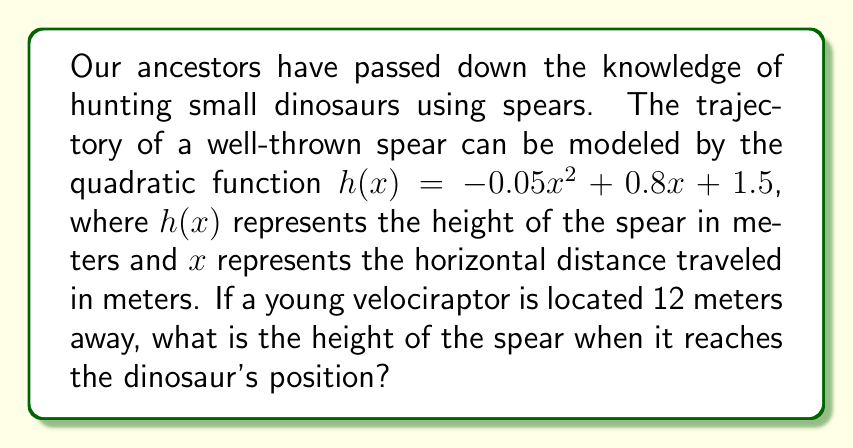Can you solve this math problem? To solve this problem, we need to follow these steps:

1) We are given the quadratic function $h(x) = -0.05x^2 + 0.8x + 1.5$

2) We need to find the height $h(x)$ when $x = 12$ meters (the position of the velociraptor)

3) To do this, we simply substitute $x = 12$ into the function:

   $h(12) = -0.05(12)^2 + 0.8(12) + 1.5$

4) Let's calculate this step by step:
   
   $h(12) = -0.05(144) + 0.8(12) + 1.5$
   
   $h(12) = -7.2 + 9.6 + 1.5$
   
   $h(12) = 3.9$

5) Therefore, when the spear reaches the velociraptor at 12 meters, its height will be 3.9 meters.

This calculation helps our hunters visualize the trajectory and aim their spears effectively to hunt small dinosaurs, as passed down by our ancestors.
Answer: $3.9$ meters 